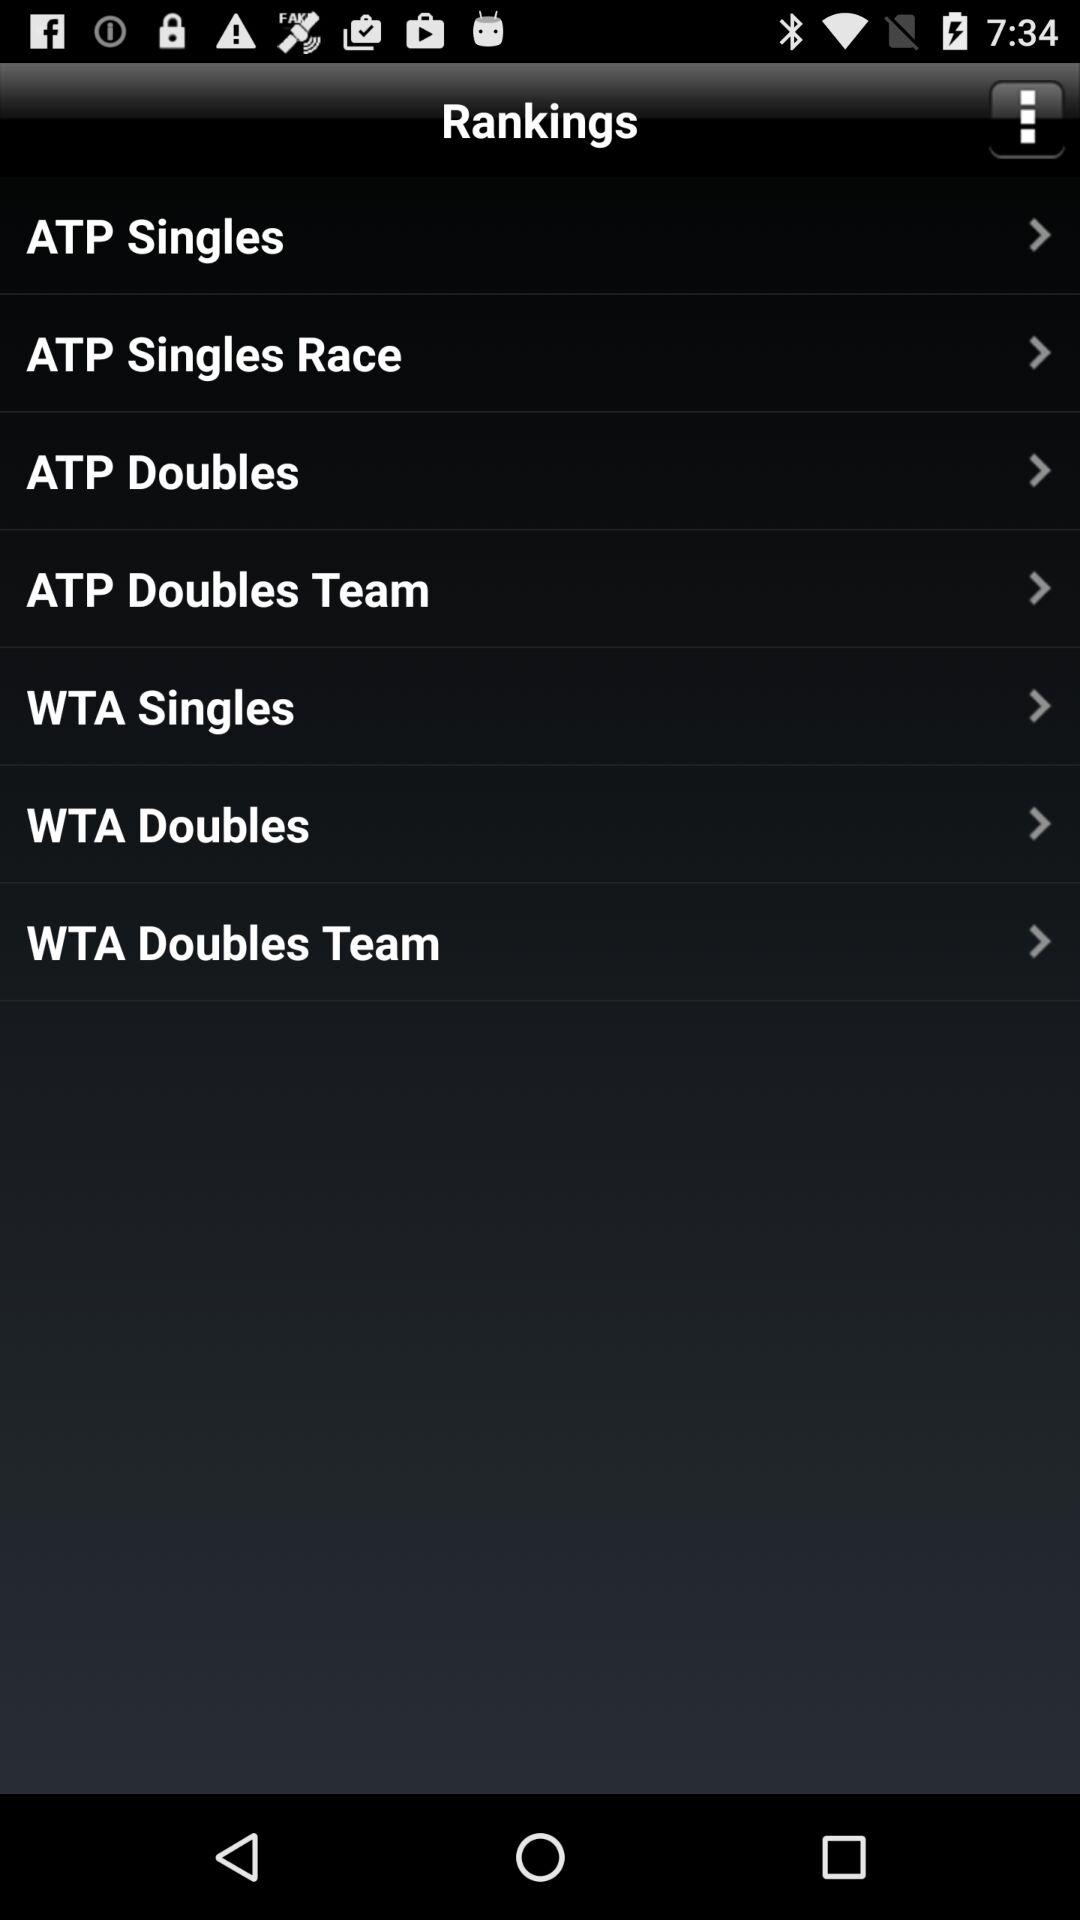How many ATP categories are there?
Answer the question using a single word or phrase. 4 